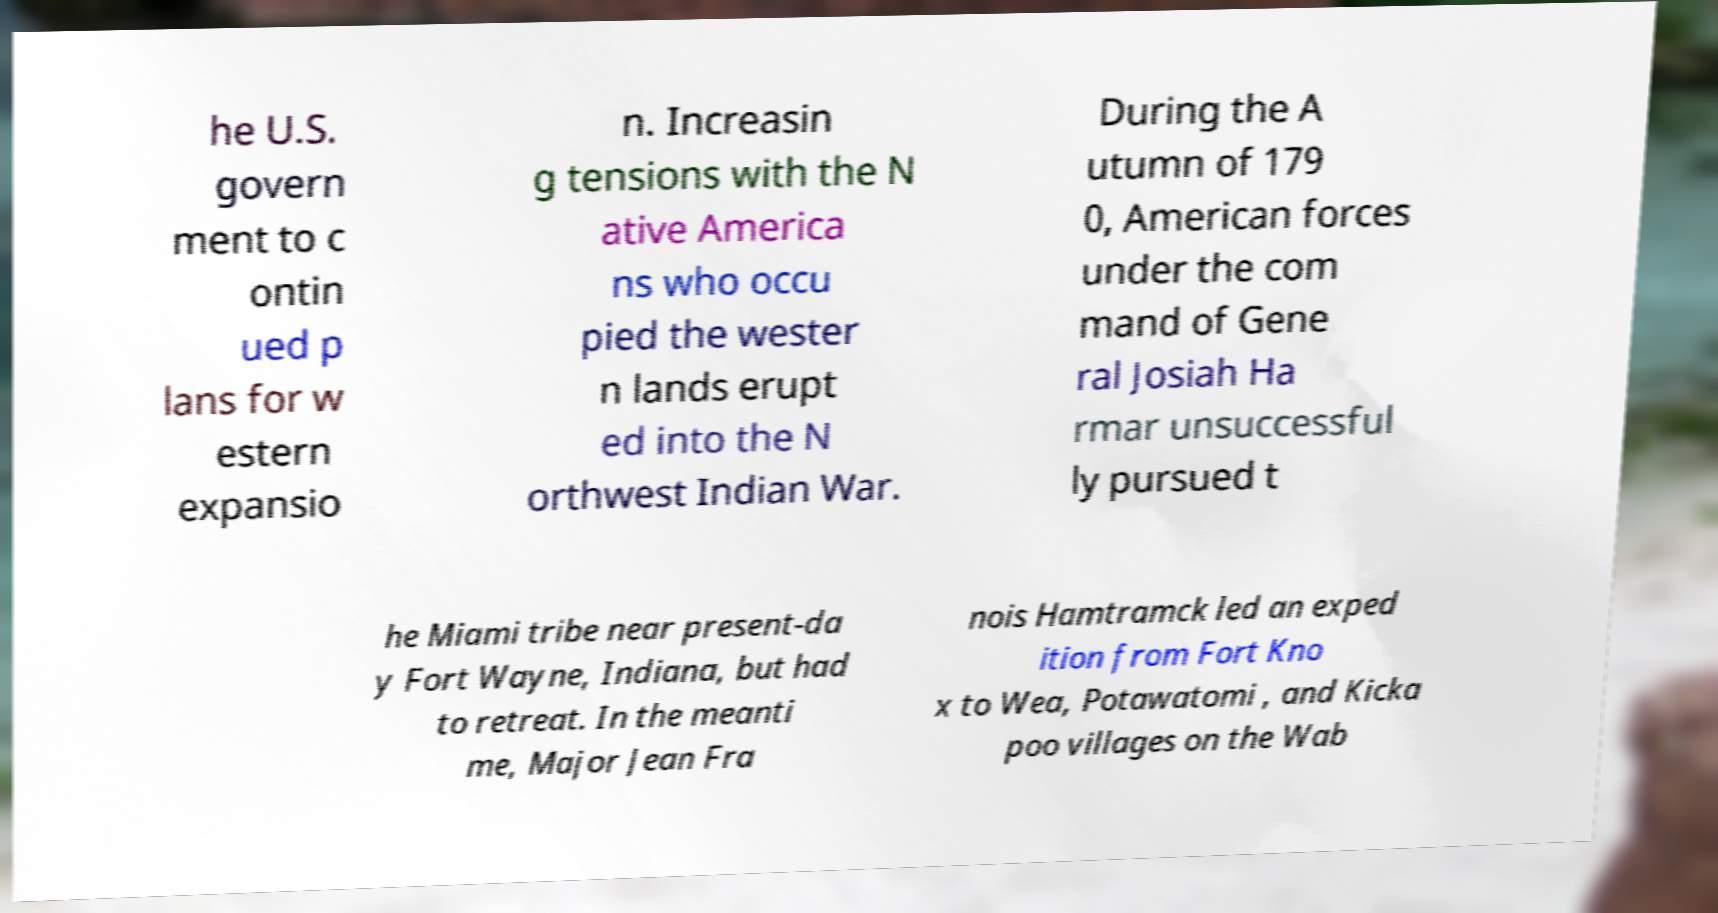Can you accurately transcribe the text from the provided image for me? he U.S. govern ment to c ontin ued p lans for w estern expansio n. Increasin g tensions with the N ative America ns who occu pied the wester n lands erupt ed into the N orthwest Indian War. During the A utumn of 179 0, American forces under the com mand of Gene ral Josiah Ha rmar unsuccessful ly pursued t he Miami tribe near present-da y Fort Wayne, Indiana, but had to retreat. In the meanti me, Major Jean Fra nois Hamtramck led an exped ition from Fort Kno x to Wea, Potawatomi , and Kicka poo villages on the Wab 